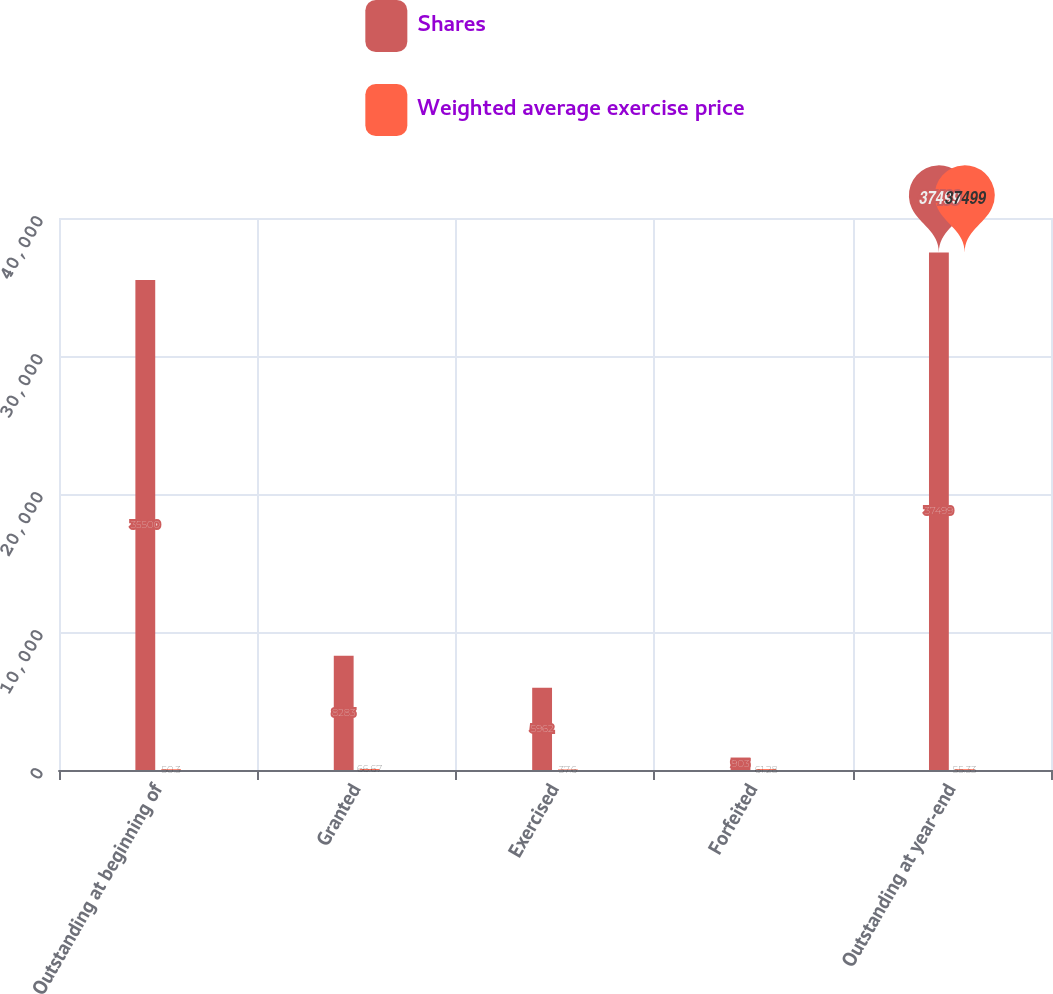Convert chart to OTSL. <chart><loc_0><loc_0><loc_500><loc_500><stacked_bar_chart><ecel><fcel>Outstanding at beginning of<fcel>Granted<fcel>Exercised<fcel>Forfeited<fcel>Outstanding at year-end<nl><fcel>Shares<fcel>35500<fcel>8283<fcel>5962<fcel>903<fcel>37499<nl><fcel>Weighted average exercise price<fcel>50.3<fcel>66.67<fcel>37.6<fcel>61.28<fcel>55.33<nl></chart> 